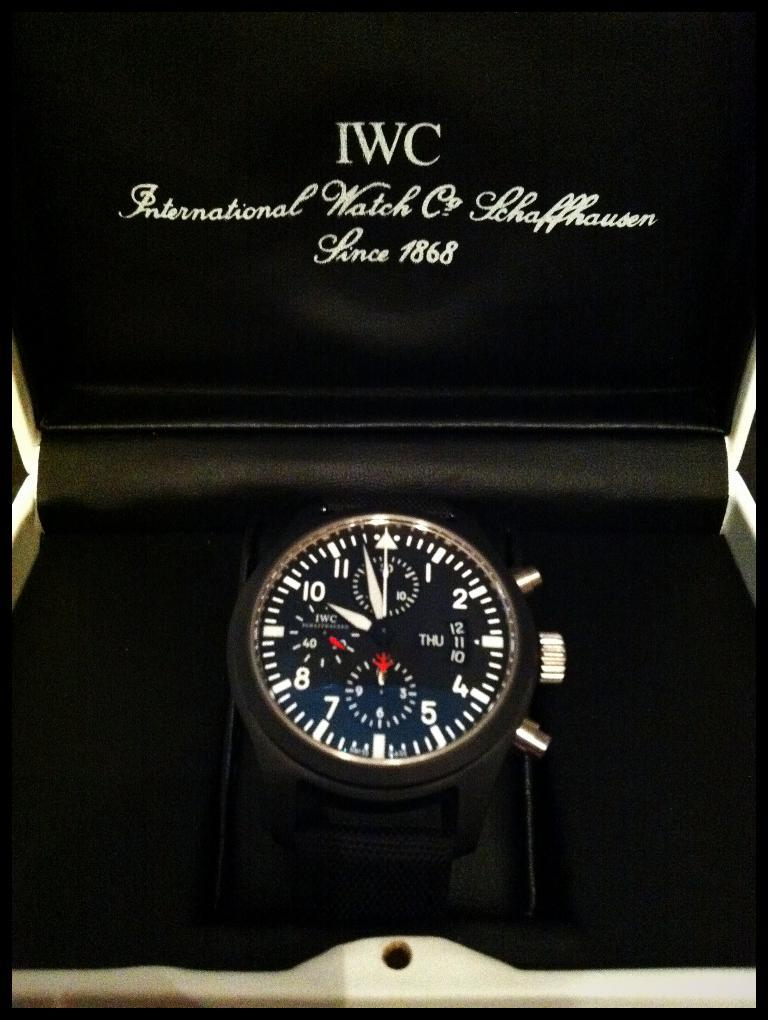<image>
Offer a succinct explanation of the picture presented. An IWC watch inside a case that says "Since 1868". 